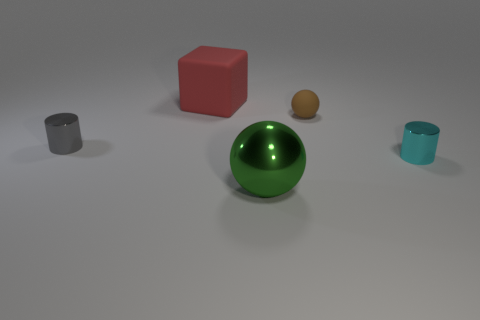There is a tiny cyan object that is made of the same material as the big green thing; what is its shape?
Ensure brevity in your answer.  Cylinder. Is there anything else that has the same shape as the large rubber object?
Your response must be concise. No. What color is the thing that is behind the gray metal object and right of the big red thing?
Provide a succinct answer. Brown. What number of cubes are gray objects or large metallic things?
Provide a succinct answer. 0. How many green metallic things have the same size as the red rubber object?
Make the answer very short. 1. There is a tiny metal object left of the big sphere; what number of tiny brown objects are in front of it?
Ensure brevity in your answer.  0. There is a thing that is to the left of the large green shiny sphere and in front of the brown matte ball; how big is it?
Your answer should be very brief. Small. Are there more red metallic blocks than cyan metal cylinders?
Ensure brevity in your answer.  No. Are there any large metallic spheres of the same color as the rubber sphere?
Your response must be concise. No. There is a cylinder that is right of the red thing; is it the same size as the matte sphere?
Your answer should be very brief. Yes. 